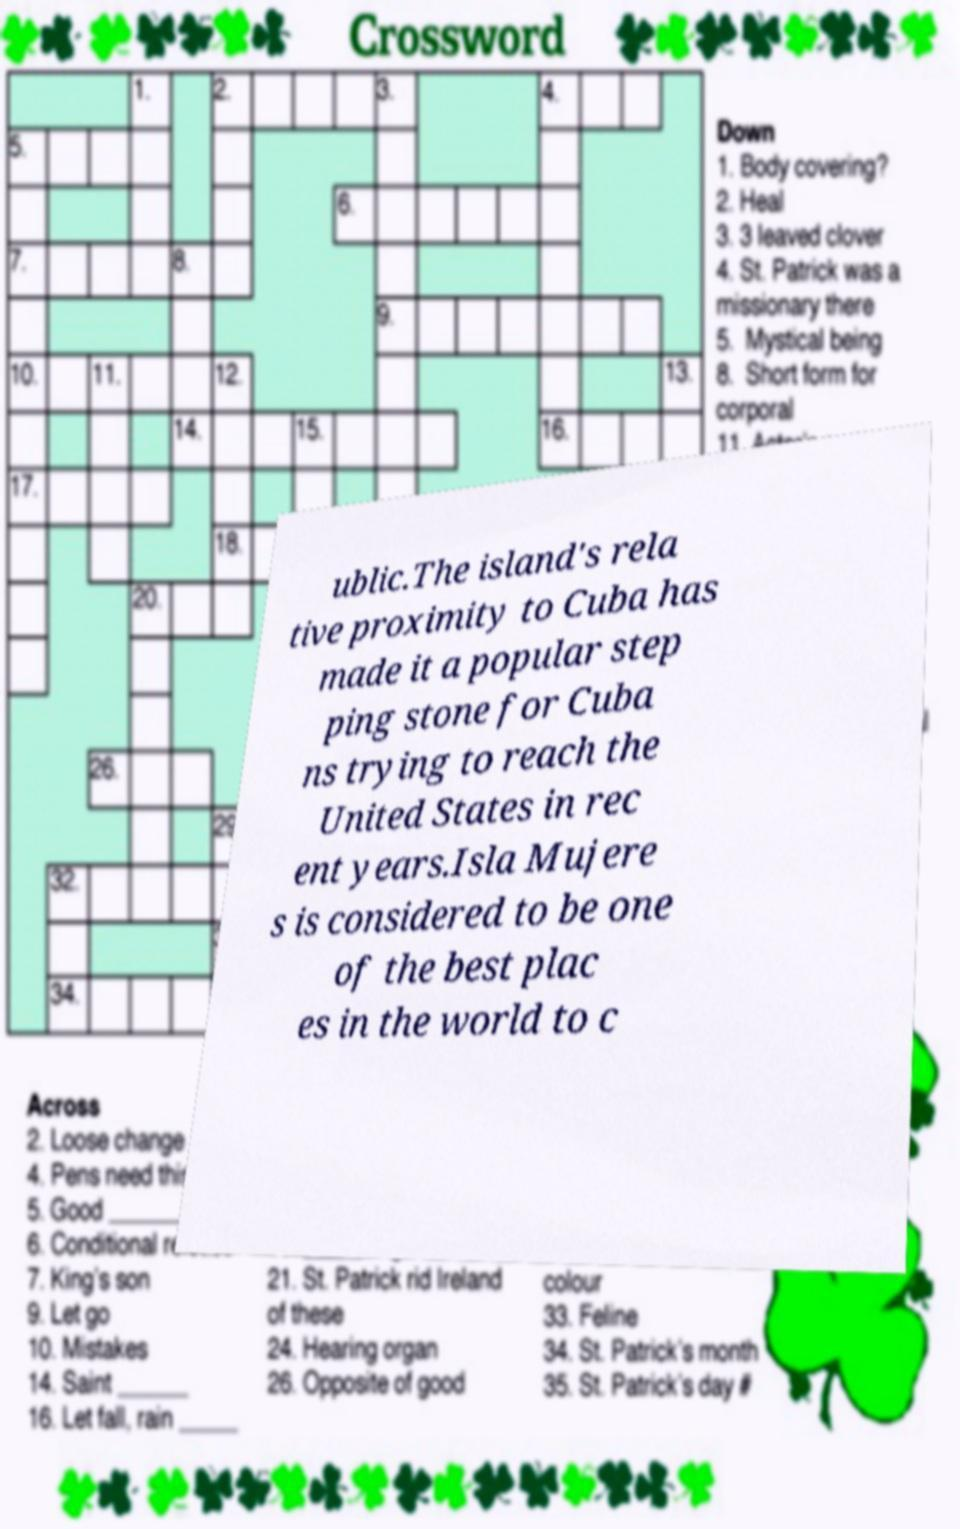What messages or text are displayed in this image? I need them in a readable, typed format. ublic.The island's rela tive proximity to Cuba has made it a popular step ping stone for Cuba ns trying to reach the United States in rec ent years.Isla Mujere s is considered to be one of the best plac es in the world to c 